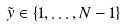Convert formula to latex. <formula><loc_0><loc_0><loc_500><loc_500>\tilde { y } \in \{ 1 , \dots , N - 1 \}</formula> 